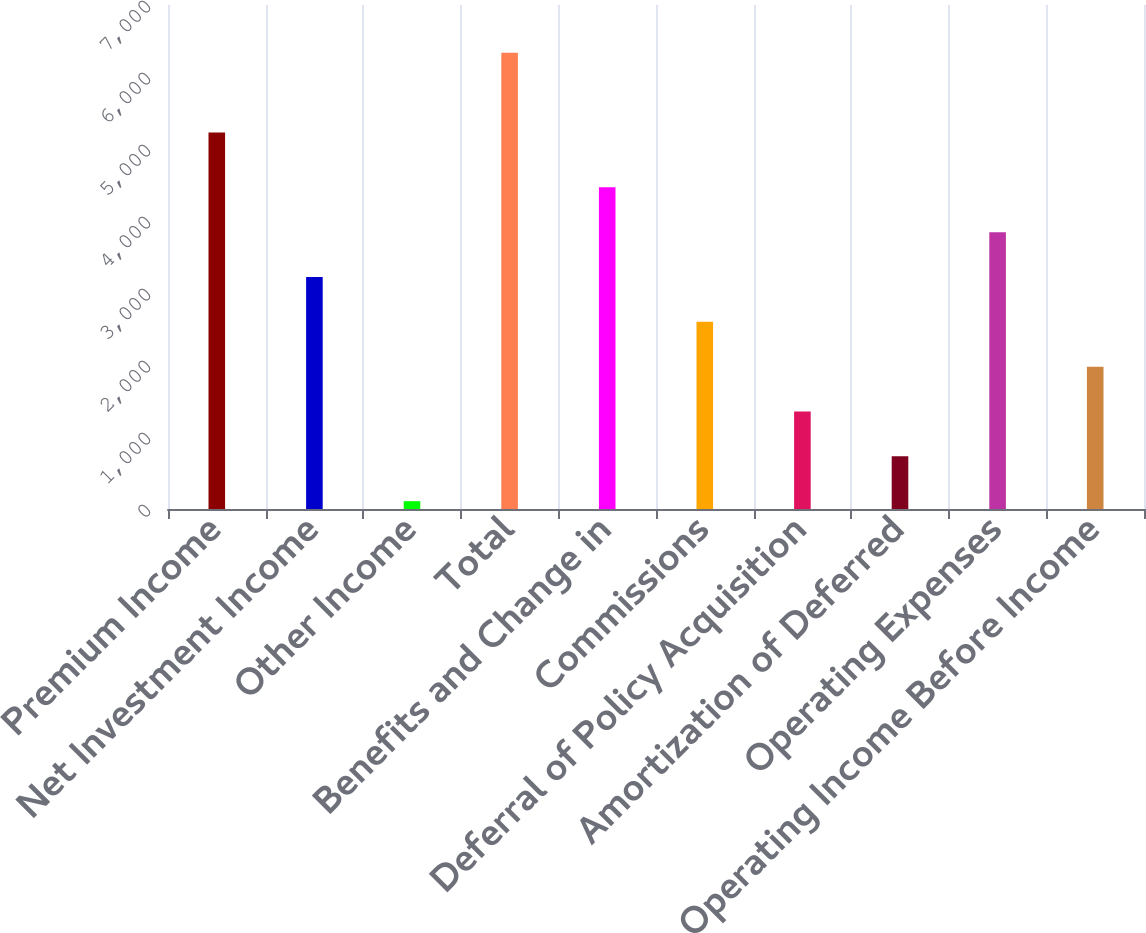Convert chart to OTSL. <chart><loc_0><loc_0><loc_500><loc_500><bar_chart><fcel>Premium Income<fcel>Net Investment Income<fcel>Other Income<fcel>Total<fcel>Benefits and Change in<fcel>Commissions<fcel>Deferral of Policy Acquisition<fcel>Amortization of Deferred<fcel>Operating Expenses<fcel>Operating Income Before Income<nl><fcel>5229<fcel>3222.2<fcel>108.6<fcel>6335.8<fcel>4467.64<fcel>2599.48<fcel>1354.04<fcel>731.32<fcel>3844.92<fcel>1976.76<nl></chart> 